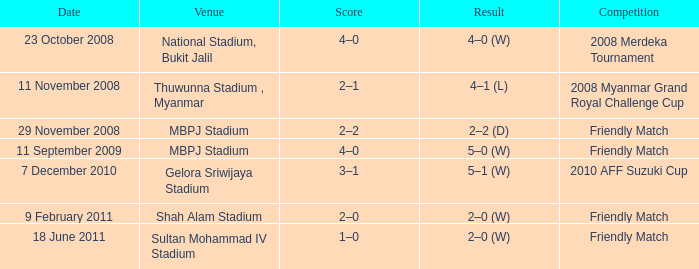What was the Score in Gelora Sriwijaya Stadium? 3–1. 